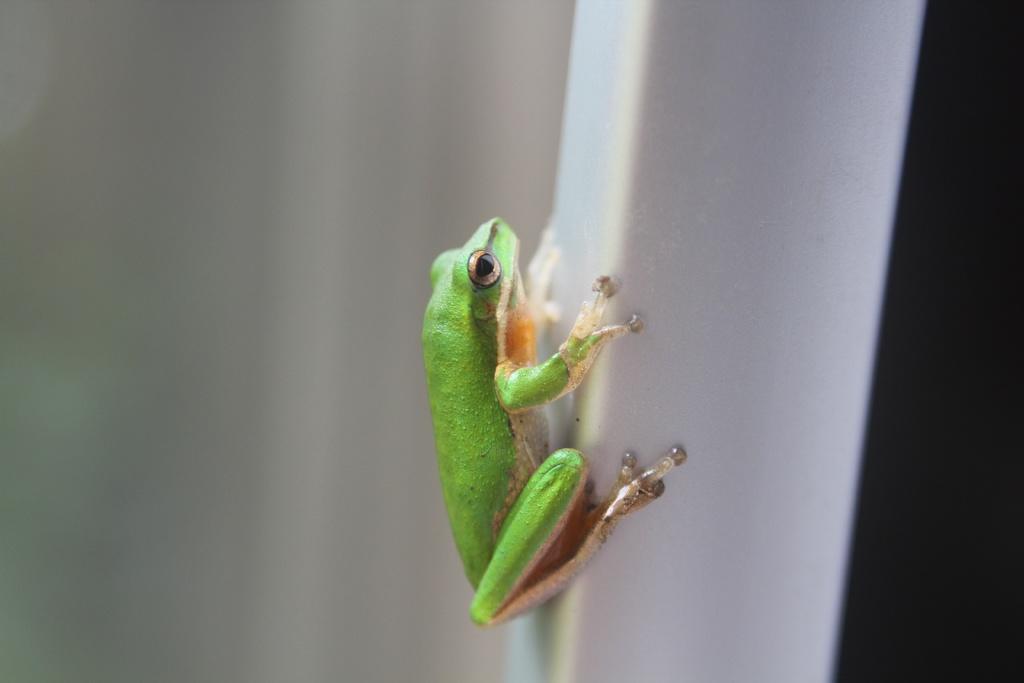In one or two sentences, can you explain what this image depicts? In this image I can see the frog which is in green, cream and brown color. It is on the white color object. And there is a white and black background. 